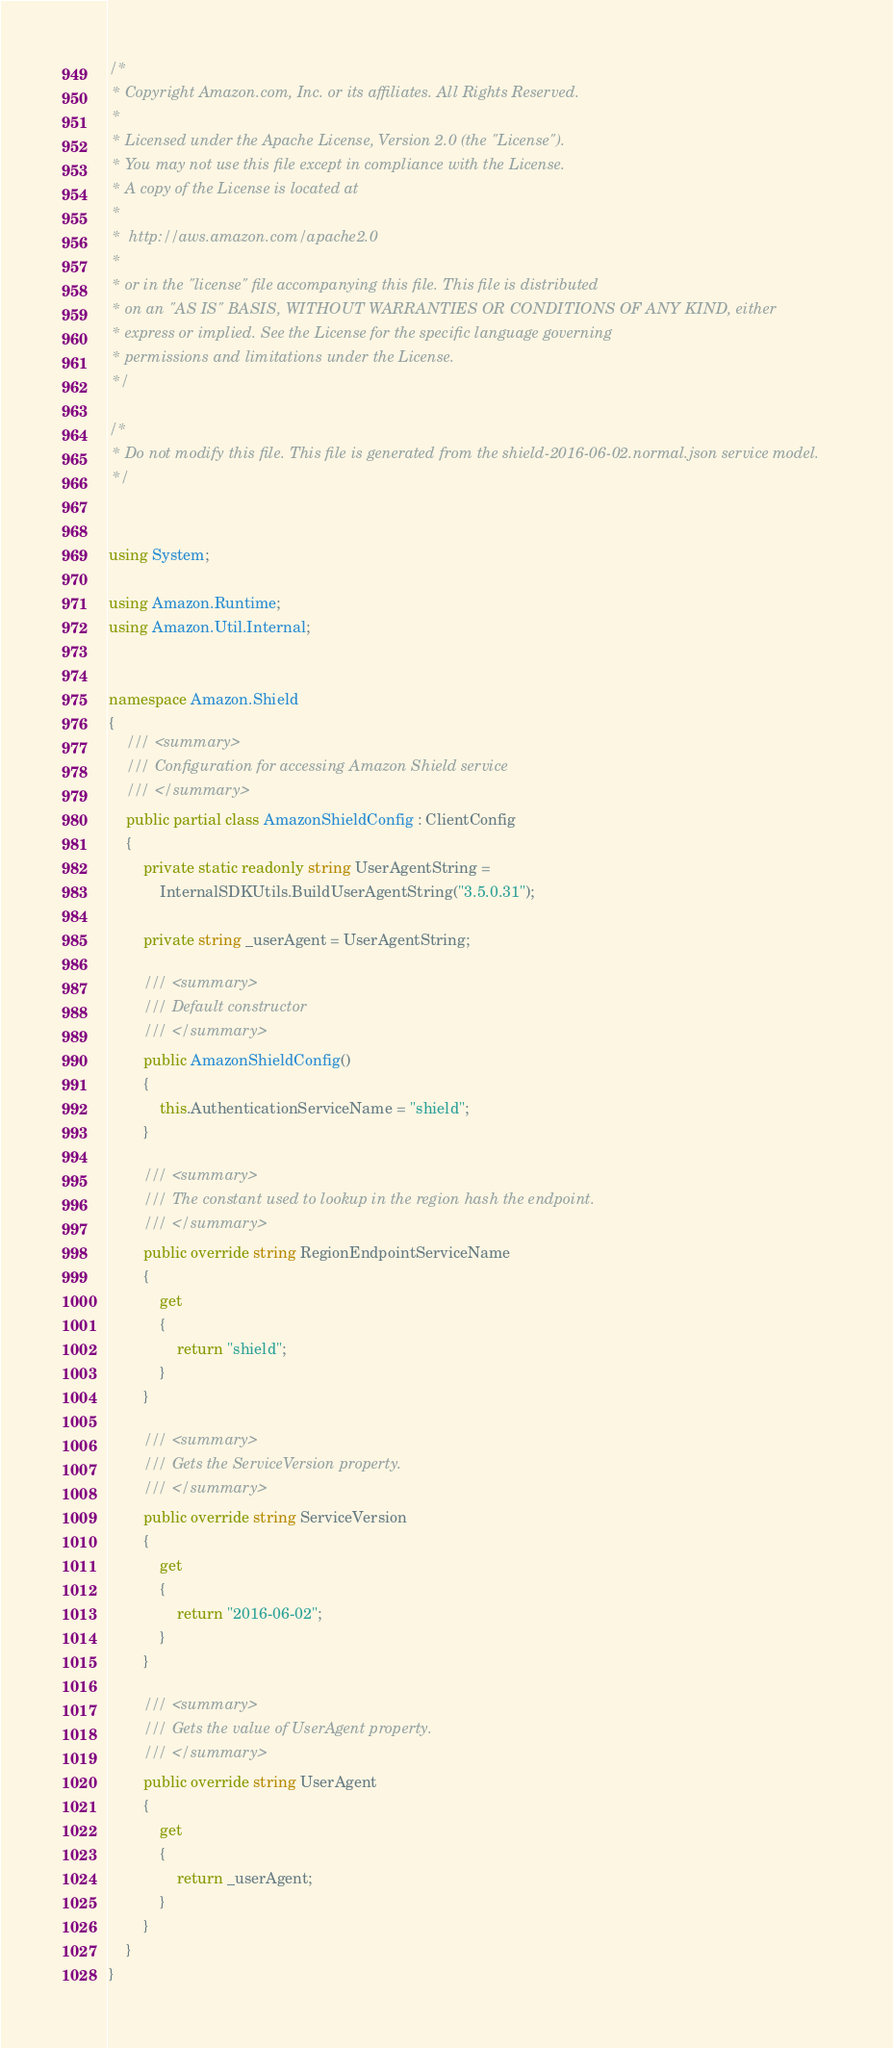<code> <loc_0><loc_0><loc_500><loc_500><_C#_>/*
 * Copyright Amazon.com, Inc. or its affiliates. All Rights Reserved.
 * 
 * Licensed under the Apache License, Version 2.0 (the "License").
 * You may not use this file except in compliance with the License.
 * A copy of the License is located at
 * 
 *  http://aws.amazon.com/apache2.0
 * 
 * or in the "license" file accompanying this file. This file is distributed
 * on an "AS IS" BASIS, WITHOUT WARRANTIES OR CONDITIONS OF ANY KIND, either
 * express or implied. See the License for the specific language governing
 * permissions and limitations under the License.
 */

/*
 * Do not modify this file. This file is generated from the shield-2016-06-02.normal.json service model.
 */


using System;

using Amazon.Runtime;
using Amazon.Util.Internal;


namespace Amazon.Shield
{
    /// <summary>
    /// Configuration for accessing Amazon Shield service
    /// </summary>
    public partial class AmazonShieldConfig : ClientConfig
    {
        private static readonly string UserAgentString =
            InternalSDKUtils.BuildUserAgentString("3.5.0.31");

        private string _userAgent = UserAgentString;

        /// <summary>
        /// Default constructor
        /// </summary>
        public AmazonShieldConfig()
        {
            this.AuthenticationServiceName = "shield";
        }

        /// <summary>
        /// The constant used to lookup in the region hash the endpoint.
        /// </summary>
        public override string RegionEndpointServiceName
        {
            get
            {
                return "shield";
            }
        }

        /// <summary>
        /// Gets the ServiceVersion property.
        /// </summary>
        public override string ServiceVersion
        {
            get
            {
                return "2016-06-02";
            }
        }

        /// <summary>
        /// Gets the value of UserAgent property.
        /// </summary>
        public override string UserAgent
        {
            get
            {
                return _userAgent;
            }
        }
    }
}</code> 